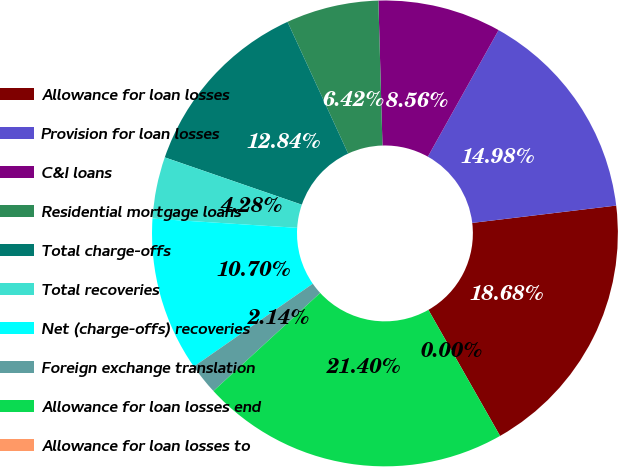Convert chart to OTSL. <chart><loc_0><loc_0><loc_500><loc_500><pie_chart><fcel>Allowance for loan losses<fcel>Provision for loan losses<fcel>C&I loans<fcel>Residential mortgage loans<fcel>Total charge-offs<fcel>Total recoveries<fcel>Net (charge-offs) recoveries<fcel>Foreign exchange translation<fcel>Allowance for loan losses end<fcel>Allowance for loan losses to<nl><fcel>18.68%<fcel>14.98%<fcel>8.56%<fcel>6.42%<fcel>12.84%<fcel>4.28%<fcel>10.7%<fcel>2.14%<fcel>21.4%<fcel>0.0%<nl></chart> 